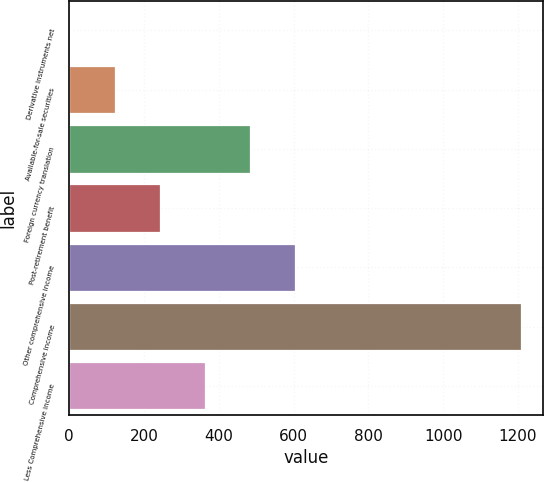Convert chart to OTSL. <chart><loc_0><loc_0><loc_500><loc_500><bar_chart><fcel>Derivative instruments net<fcel>Available-for-sale securities<fcel>Foreign currency translation<fcel>Post-retirement benefit<fcel>Other comprehensive income<fcel>Comprehensive income<fcel>Less Comprehensive income<nl><fcel>1<fcel>121.6<fcel>483.4<fcel>242.2<fcel>604<fcel>1207<fcel>362.8<nl></chart> 